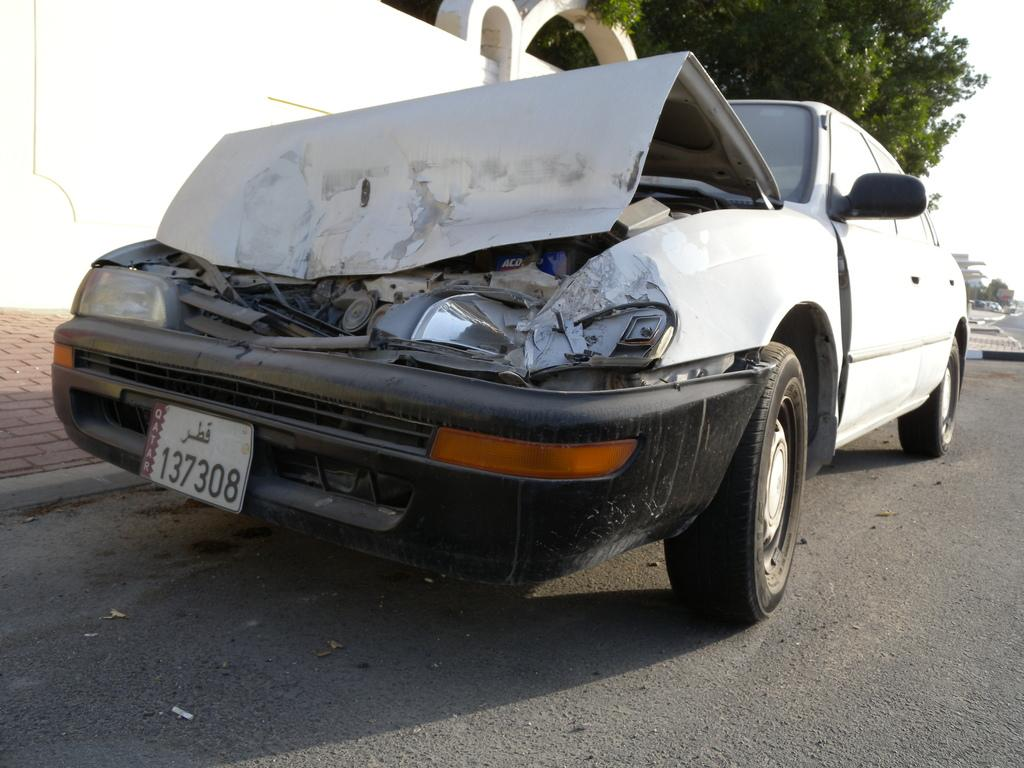What is the main subject of the image? The main subject of the image is a crashed car. Is there any information about the car's identity in the image? Yes, there is a name plate attached to the car. What can be seen in the background of the image? There is a tree and a wall visible in the image. Where is the car located in the image? The car is visible on the road. How does the brother of the car's owner feel about the crash? There is no information about the car's owner or their brother in the image, so we cannot determine their feelings. 